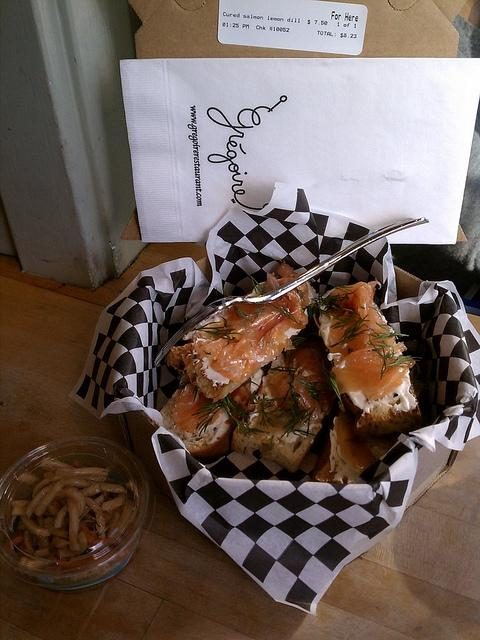The basket of salmon is currently being eaten at which location? restaurant 